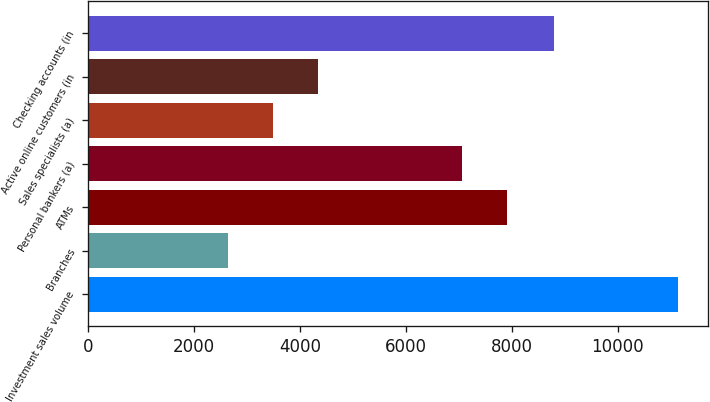<chart> <loc_0><loc_0><loc_500><loc_500><bar_chart><fcel>Investment sales volume<fcel>Branches<fcel>ATMs<fcel>Personal bankers (a)<fcel>Sales specialists (a)<fcel>Active online customers (in<fcel>Checking accounts (in<nl><fcel>11144<fcel>2641<fcel>7917.3<fcel>7067<fcel>3491.3<fcel>4341.6<fcel>8793<nl></chart> 